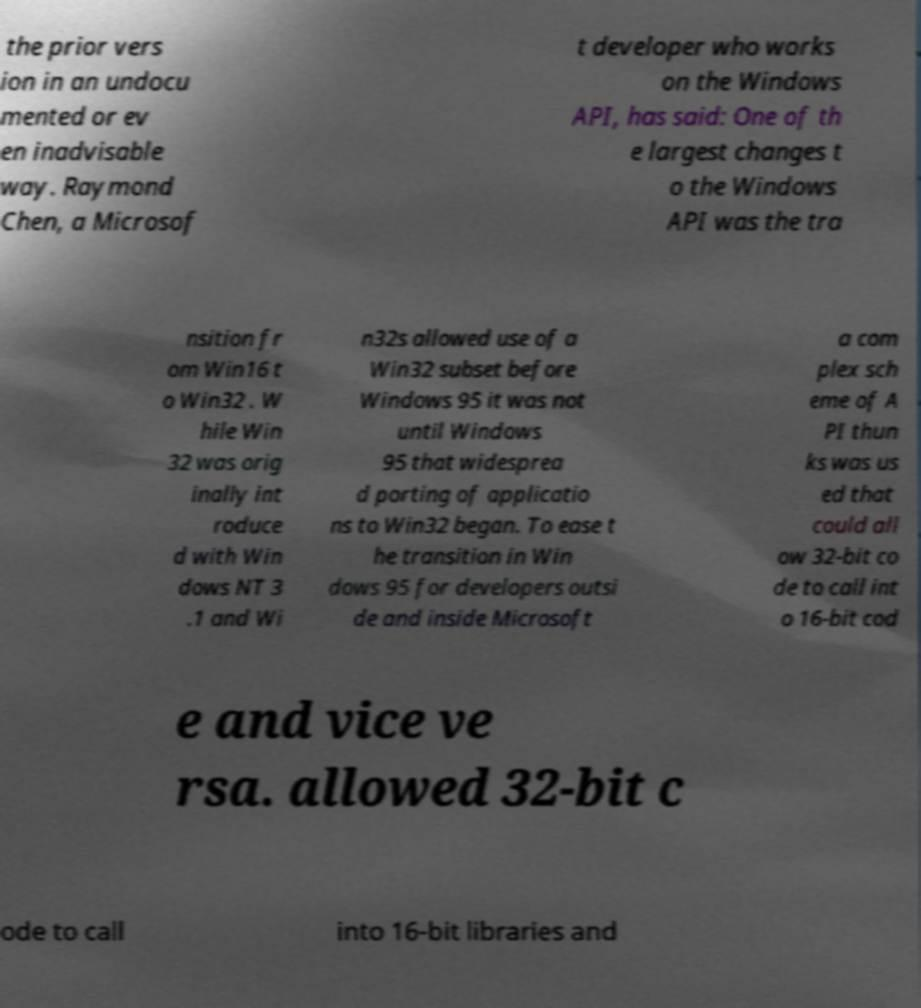Can you accurately transcribe the text from the provided image for me? the prior vers ion in an undocu mented or ev en inadvisable way. Raymond Chen, a Microsof t developer who works on the Windows API, has said: One of th e largest changes t o the Windows API was the tra nsition fr om Win16 t o Win32 . W hile Win 32 was orig inally int roduce d with Win dows NT 3 .1 and Wi n32s allowed use of a Win32 subset before Windows 95 it was not until Windows 95 that widesprea d porting of applicatio ns to Win32 began. To ease t he transition in Win dows 95 for developers outsi de and inside Microsoft a com plex sch eme of A PI thun ks was us ed that could all ow 32-bit co de to call int o 16-bit cod e and vice ve rsa. allowed 32-bit c ode to call into 16-bit libraries and 